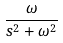Convert formula to latex. <formula><loc_0><loc_0><loc_500><loc_500>\frac { \omega } { s ^ { 2 } + \omega ^ { 2 } }</formula> 